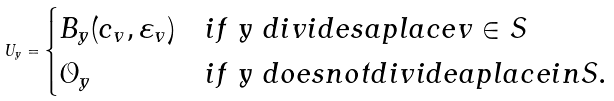Convert formula to latex. <formula><loc_0><loc_0><loc_500><loc_500>U _ { y } = \begin{cases} B _ { y } ( c _ { v } , \varepsilon _ { v } ) & i f $ y $ d i v i d e s a p l a c e v \in S \\ \mathcal { O } _ { y } & i f $ y $ d o e s n o t d i v i d e a p l a c e i n S . \end{cases}</formula> 